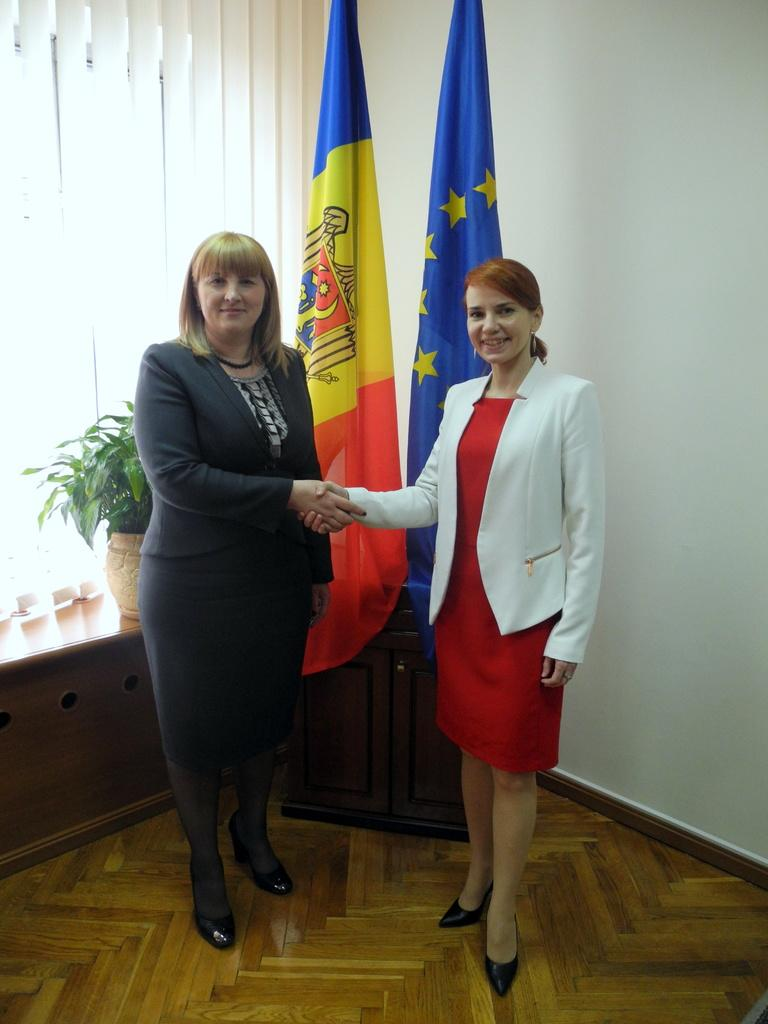How many women are present in the image? There are two women standing in the image. We start by identifying the number of people in the image, which is two women. Then, we describe their position, stating that they are standing on the floor. Next, we mention the presence of two flags, a flower pot, and a white color wall, which are other elements visible in the image. Absurd Question/Answer: What type of prose is being recited by the women in the image? There is no indication in the image that the women are reciting any prose or engaging in any verbal communication. What type of angle is being used to capture the image? There is no information about the angle used to capture the image, as we are only looking at the image and not considering the camera or photography techniques. 